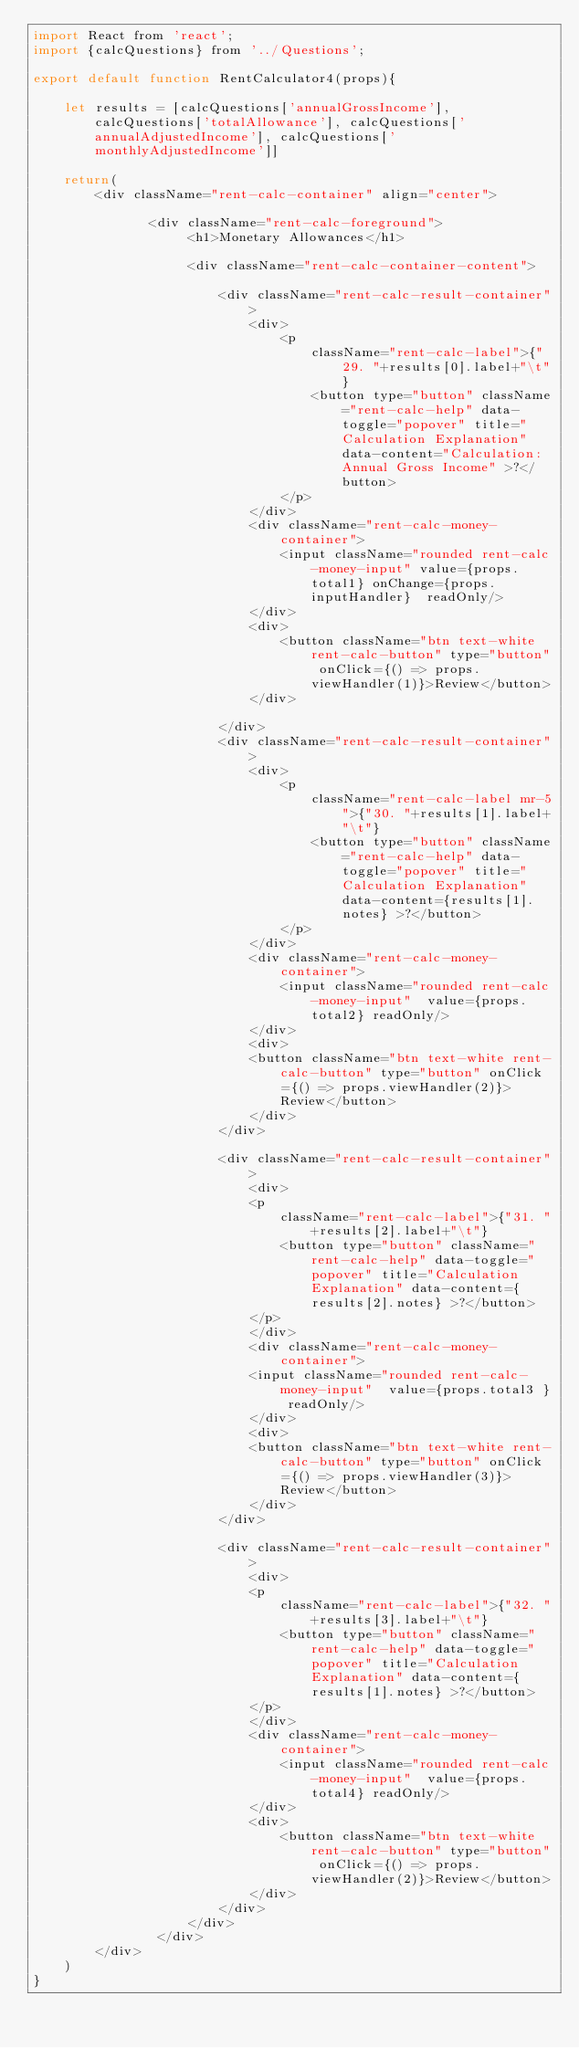Convert code to text. <code><loc_0><loc_0><loc_500><loc_500><_JavaScript_>import React from 'react';
import {calcQuestions} from '../Questions';

export default function RentCalculator4(props){ 
   
    let results = [calcQuestions['annualGrossIncome'], calcQuestions['totalAllowance'], calcQuestions['annualAdjustedIncome'], calcQuestions['monthlyAdjustedIncome']]
    
    return(
        <div className="rent-calc-container" align="center">
               
               <div className="rent-calc-foreground">
                    <h1>Monetary Allowances</h1>

                    <div className="rent-calc-container-content">

                        <div className="rent-calc-result-container">
                            <div>
                                <p 
                                    className="rent-calc-label">{"29. "+results[0].label+"\t"}
                                    <button type="button" className="rent-calc-help" data-toggle="popover" title="Calculation Explanation" data-content="Calculation: Annual Gross Income" >?</button>
                                </p>
                            </div>
                            <div className="rent-calc-money-container">
                                <input className="rounded rent-calc-money-input" value={props.total1} onChange={props.inputHandler}  readOnly/>
                            </div>
                            <div>
                                <button className="btn text-white rent-calc-button" type="button" onClick={() => props.viewHandler(1)}>Review</button>
                            </div>
                            
                        </div>
                        <div className="rent-calc-result-container">
                            <div>
                                <p 
                                    className="rent-calc-label mr-5">{"30. "+results[1].label+"\t"}
                                    <button type="button" className="rent-calc-help" data-toggle="popover" title="Calculation Explanation" data-content={results[1].notes} >?</button>
                                </p>
                            </div>
                            <div className="rent-calc-money-container">
                                <input className="rounded rent-calc-money-input"  value={props.total2} readOnly/>
                            </div>
                            <div>
                            <button className="btn text-white rent-calc-button" type="button" onClick={() => props.viewHandler(2)}>Review</button>
                            </div>
                        </div>

                        <div className="rent-calc-result-container">
                            <div>
                            <p 
                                className="rent-calc-label">{"31. "+results[2].label+"\t"}
                                <button type="button" className="rent-calc-help" data-toggle="popover" title="Calculation Explanation" data-content={results[2].notes} >?</button>
                            </p>
                            </div>
                            <div className="rent-calc-money-container">
                            <input className="rounded rent-calc-money-input"  value={props.total3 } readOnly/>
                            </div>
                            <div>
                            <button className="btn text-white rent-calc-button" type="button" onClick={() => props.viewHandler(3)}>Review</button>
                            </div>
                        </div>

                        <div className="rent-calc-result-container">
                            <div>
                            <p 
                                className="rent-calc-label">{"32. "+results[3].label+"\t"}
                                <button type="button" className="rent-calc-help" data-toggle="popover" title="Calculation Explanation" data-content={results[1].notes} >?</button>
                            </p>
                            </div>
                            <div className="rent-calc-money-container">
                                <input className="rounded rent-calc-money-input"  value={props.total4} readOnly/>
                            </div>
                            <div>
                                <button className="btn text-white rent-calc-button" type="button" onClick={() => props.viewHandler(2)}>Review</button>
                            </div>
                        </div>
                    </div>
                </div>
        </div>    
    )  
}
</code> 